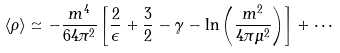<formula> <loc_0><loc_0><loc_500><loc_500>\langle \rho \rangle \simeq - \frac { m ^ { 4 } } { 6 4 \pi ^ { 2 } } \left [ \frac { 2 } { \epsilon } + \frac { 3 } { 2 } - \gamma - \ln \left ( \frac { m ^ { 2 } } { 4 \pi \mu ^ { 2 } } \right ) \right ] + \cdots</formula> 